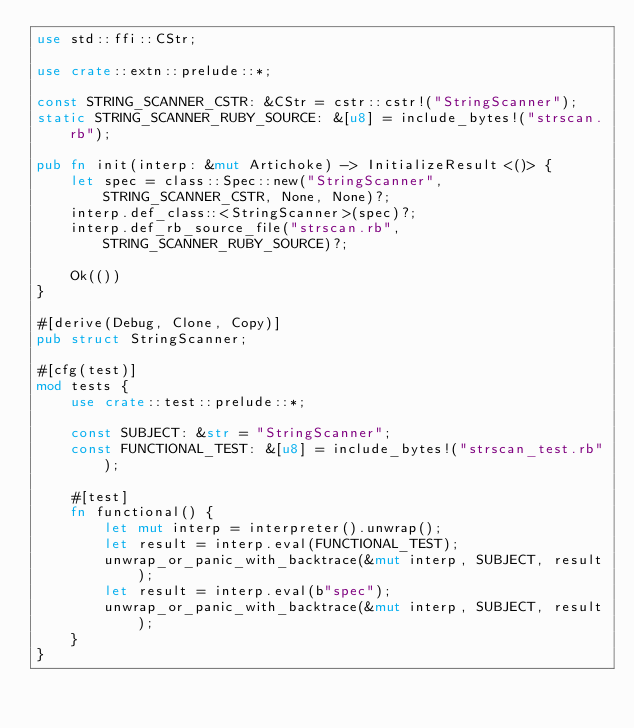<code> <loc_0><loc_0><loc_500><loc_500><_Rust_>use std::ffi::CStr;

use crate::extn::prelude::*;

const STRING_SCANNER_CSTR: &CStr = cstr::cstr!("StringScanner");
static STRING_SCANNER_RUBY_SOURCE: &[u8] = include_bytes!("strscan.rb");

pub fn init(interp: &mut Artichoke) -> InitializeResult<()> {
    let spec = class::Spec::new("StringScanner", STRING_SCANNER_CSTR, None, None)?;
    interp.def_class::<StringScanner>(spec)?;
    interp.def_rb_source_file("strscan.rb", STRING_SCANNER_RUBY_SOURCE)?;

    Ok(())
}

#[derive(Debug, Clone, Copy)]
pub struct StringScanner;

#[cfg(test)]
mod tests {
    use crate::test::prelude::*;

    const SUBJECT: &str = "StringScanner";
    const FUNCTIONAL_TEST: &[u8] = include_bytes!("strscan_test.rb");

    #[test]
    fn functional() {
        let mut interp = interpreter().unwrap();
        let result = interp.eval(FUNCTIONAL_TEST);
        unwrap_or_panic_with_backtrace(&mut interp, SUBJECT, result);
        let result = interp.eval(b"spec");
        unwrap_or_panic_with_backtrace(&mut interp, SUBJECT, result);
    }
}
</code> 